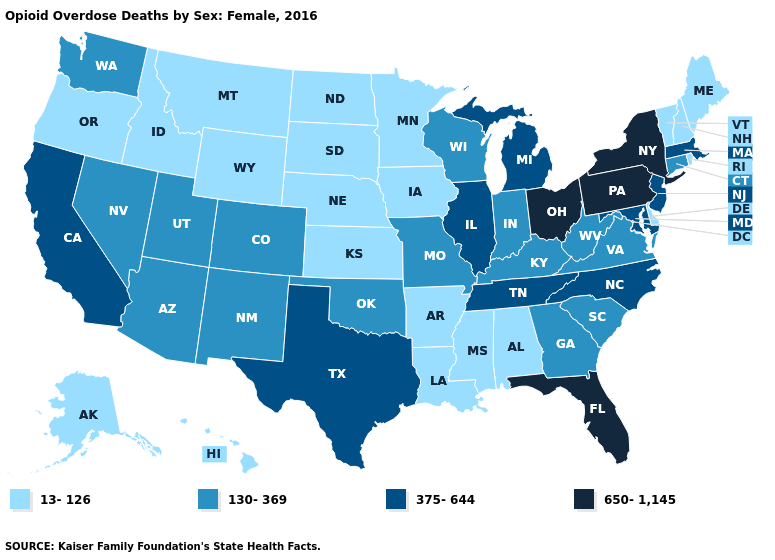What is the value of Virginia?
Give a very brief answer. 130-369. Name the states that have a value in the range 13-126?
Quick response, please. Alabama, Alaska, Arkansas, Delaware, Hawaii, Idaho, Iowa, Kansas, Louisiana, Maine, Minnesota, Mississippi, Montana, Nebraska, New Hampshire, North Dakota, Oregon, Rhode Island, South Dakota, Vermont, Wyoming. Name the states that have a value in the range 130-369?
Write a very short answer. Arizona, Colorado, Connecticut, Georgia, Indiana, Kentucky, Missouri, Nevada, New Mexico, Oklahoma, South Carolina, Utah, Virginia, Washington, West Virginia, Wisconsin. Which states hav the highest value in the West?
Concise answer only. California. Does New Jersey have the same value as Tennessee?
Concise answer only. Yes. How many symbols are there in the legend?
Quick response, please. 4. How many symbols are there in the legend?
Keep it brief. 4. Does New York have the same value as Mississippi?
Quick response, please. No. Name the states that have a value in the range 375-644?
Be succinct. California, Illinois, Maryland, Massachusetts, Michigan, New Jersey, North Carolina, Tennessee, Texas. What is the value of Vermont?
Short answer required. 13-126. Among the states that border Texas , which have the lowest value?
Concise answer only. Arkansas, Louisiana. What is the highest value in the MidWest ?
Be succinct. 650-1,145. Among the states that border New Hampshire , does Maine have the lowest value?
Give a very brief answer. Yes. What is the value of California?
Write a very short answer. 375-644. Name the states that have a value in the range 13-126?
Short answer required. Alabama, Alaska, Arkansas, Delaware, Hawaii, Idaho, Iowa, Kansas, Louisiana, Maine, Minnesota, Mississippi, Montana, Nebraska, New Hampshire, North Dakota, Oregon, Rhode Island, South Dakota, Vermont, Wyoming. 